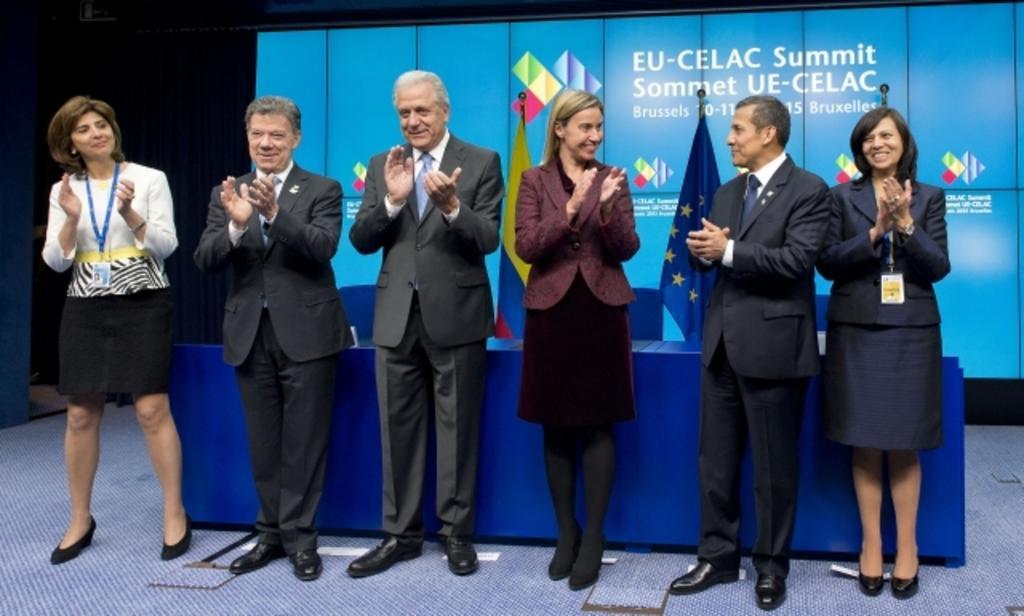How would you summarize this image in a sentence or two? In this image, we can see a group of people are standing on the floor. They are smiling and clapping their hands. Background we can see flags, screen, curtain. Here there is a desk and chairs. 